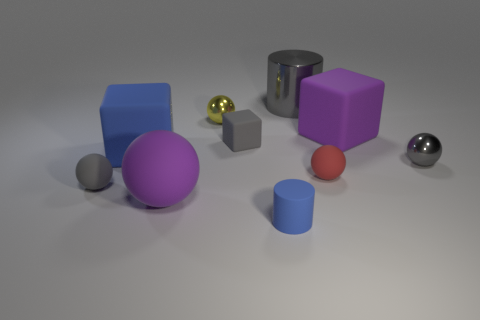What number of small red balls are there?
Ensure brevity in your answer.  1. The purple rubber thing that is in front of the big purple rubber block has what shape?
Provide a short and direct response. Sphere. The big matte thing in front of the large block that is in front of the big purple object to the right of the blue cylinder is what color?
Offer a terse response. Purple. There is a large blue thing that is made of the same material as the small red sphere; what is its shape?
Provide a succinct answer. Cube. Are there fewer brown metal blocks than yellow objects?
Give a very brief answer. Yes. Does the purple block have the same material as the large gray cylinder?
Offer a very short reply. No. How many other objects are the same color as the large matte ball?
Make the answer very short. 1. Are there more tiny blue metal cylinders than matte cubes?
Provide a succinct answer. No. There is a matte cylinder; is it the same size as the purple matte object that is in front of the large blue thing?
Make the answer very short. No. The tiny rubber ball on the right side of the yellow metal object is what color?
Provide a succinct answer. Red. 